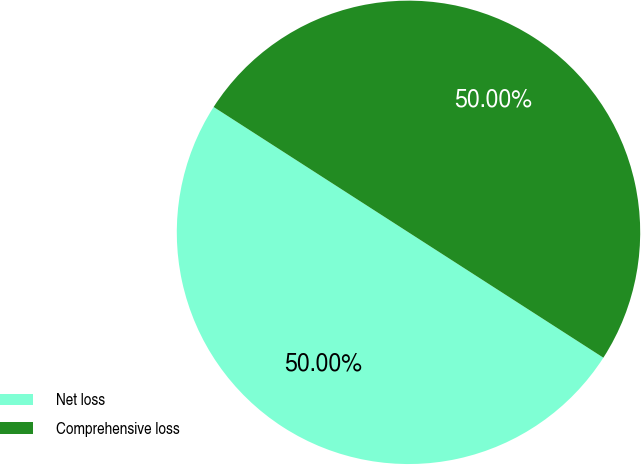Convert chart to OTSL. <chart><loc_0><loc_0><loc_500><loc_500><pie_chart><fcel>Net loss<fcel>Comprehensive loss<nl><fcel>50.0%<fcel>50.0%<nl></chart> 